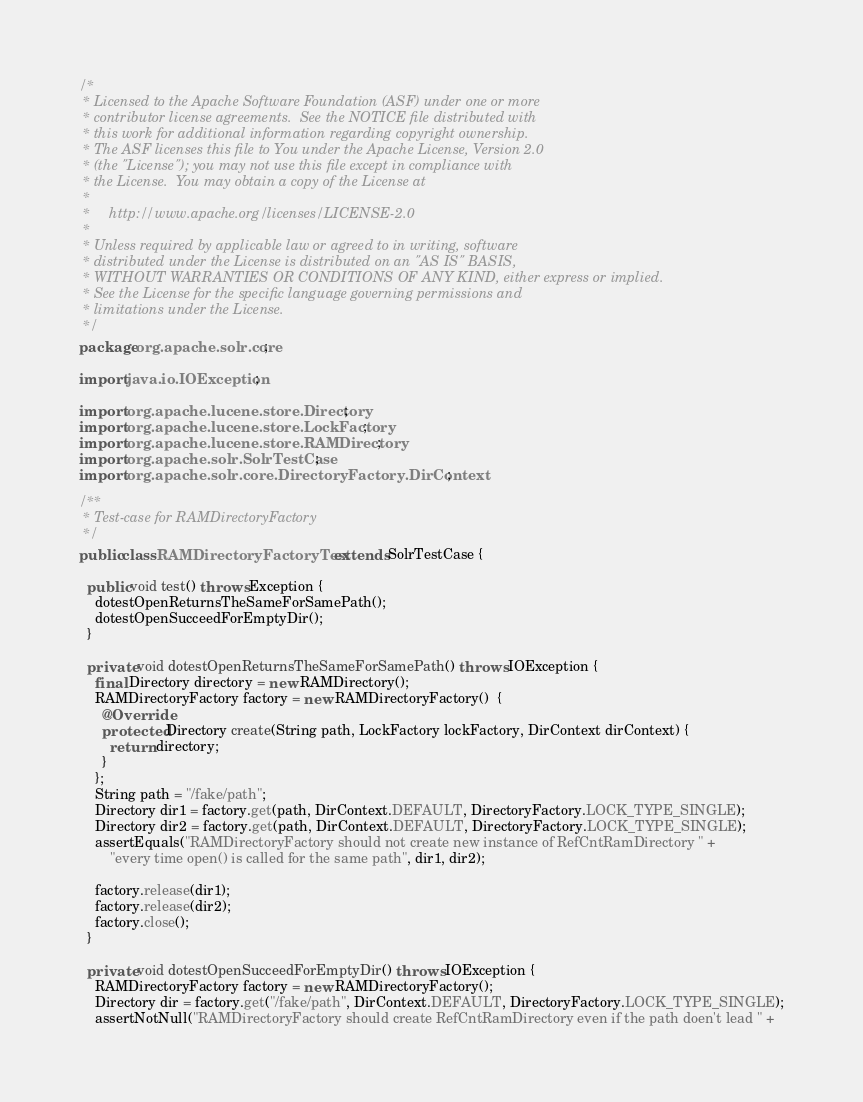Convert code to text. <code><loc_0><loc_0><loc_500><loc_500><_Java_>/*
 * Licensed to the Apache Software Foundation (ASF) under one or more
 * contributor license agreements.  See the NOTICE file distributed with
 * this work for additional information regarding copyright ownership.
 * The ASF licenses this file to You under the Apache License, Version 2.0
 * (the "License"); you may not use this file except in compliance with
 * the License.  You may obtain a copy of the License at
 *
 *     http://www.apache.org/licenses/LICENSE-2.0
 *
 * Unless required by applicable law or agreed to in writing, software
 * distributed under the License is distributed on an "AS IS" BASIS,
 * WITHOUT WARRANTIES OR CONDITIONS OF ANY KIND, either express or implied.
 * See the License for the specific language governing permissions and
 * limitations under the License.
 */
package org.apache.solr.core;

import java.io.IOException;

import org.apache.lucene.store.Directory;
import org.apache.lucene.store.LockFactory;
import org.apache.lucene.store.RAMDirectory;
import org.apache.solr.SolrTestCase;
import org.apache.solr.core.DirectoryFactory.DirContext;

/**
 * Test-case for RAMDirectoryFactory
 */
public class RAMDirectoryFactoryTest extends SolrTestCase {

  public void test() throws Exception {
    dotestOpenReturnsTheSameForSamePath();
    dotestOpenSucceedForEmptyDir();
  }

  private void dotestOpenReturnsTheSameForSamePath() throws IOException {
    final Directory directory = new RAMDirectory();
    RAMDirectoryFactory factory = new RAMDirectoryFactory()  {
      @Override
      protected Directory create(String path, LockFactory lockFactory, DirContext dirContext) {
        return directory;
      }
    };
    String path = "/fake/path";
    Directory dir1 = factory.get(path, DirContext.DEFAULT, DirectoryFactory.LOCK_TYPE_SINGLE);
    Directory dir2 = factory.get(path, DirContext.DEFAULT, DirectoryFactory.LOCK_TYPE_SINGLE);
    assertEquals("RAMDirectoryFactory should not create new instance of RefCntRamDirectory " +
        "every time open() is called for the same path", dir1, dir2);

    factory.release(dir1);
    factory.release(dir2);
    factory.close();
  }

  private void dotestOpenSucceedForEmptyDir() throws IOException {
    RAMDirectoryFactory factory = new RAMDirectoryFactory();
    Directory dir = factory.get("/fake/path", DirContext.DEFAULT, DirectoryFactory.LOCK_TYPE_SINGLE);
    assertNotNull("RAMDirectoryFactory should create RefCntRamDirectory even if the path doen't lead " +</code> 